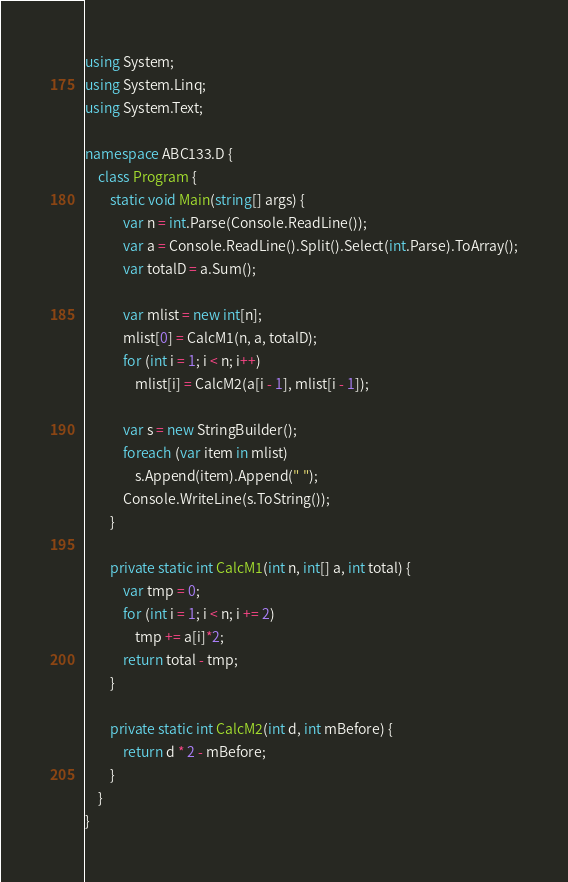Convert code to text. <code><loc_0><loc_0><loc_500><loc_500><_C#_>using System;
using System.Linq;
using System.Text;

namespace ABC133.D {
    class Program {
        static void Main(string[] args) {
            var n = int.Parse(Console.ReadLine());
            var a = Console.ReadLine().Split().Select(int.Parse).ToArray();
            var totalD = a.Sum();

            var mlist = new int[n];
            mlist[0] = CalcM1(n, a, totalD);
            for (int i = 1; i < n; i++)
                mlist[i] = CalcM2(a[i - 1], mlist[i - 1]);

            var s = new StringBuilder();
            foreach (var item in mlist)
                s.Append(item).Append(" ");
            Console.WriteLine(s.ToString());
        }

        private static int CalcM1(int n, int[] a, int total) {
            var tmp = 0;
            for (int i = 1; i < n; i += 2)
                tmp += a[i]*2;
            return total - tmp;
        }

        private static int CalcM2(int d, int mBefore) {
            return d * 2 - mBefore;
        }
    }
}
</code> 